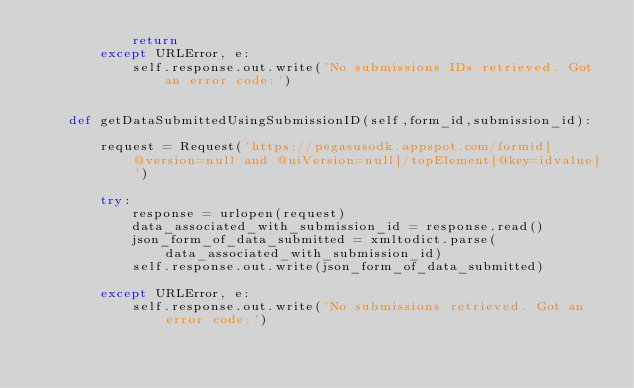<code> <loc_0><loc_0><loc_500><loc_500><_Python_>            return
        except URLError, e:
            self.response.out.write('No submissions IDs retrieved. Got an error code:')


    def getDataSubmittedUsingSubmissionID(self,form_id,submission_id):

        request = Request('https://pegasusodk.appspot.com/formid[@version=null and @uiVersion=null]/topElement[@key=idvalue]')

        try:
            response = urlopen(request)
            data_associated_with_submission_id = response.read()
            json_form_of_data_submitted = xmltodict.parse(data_associated_with_submission_id)
            self.response.out.write(json_form_of_data_submitted)

        except URLError, e:
            self.response.out.write('No submissions retrieved. Got an error code:')




</code> 